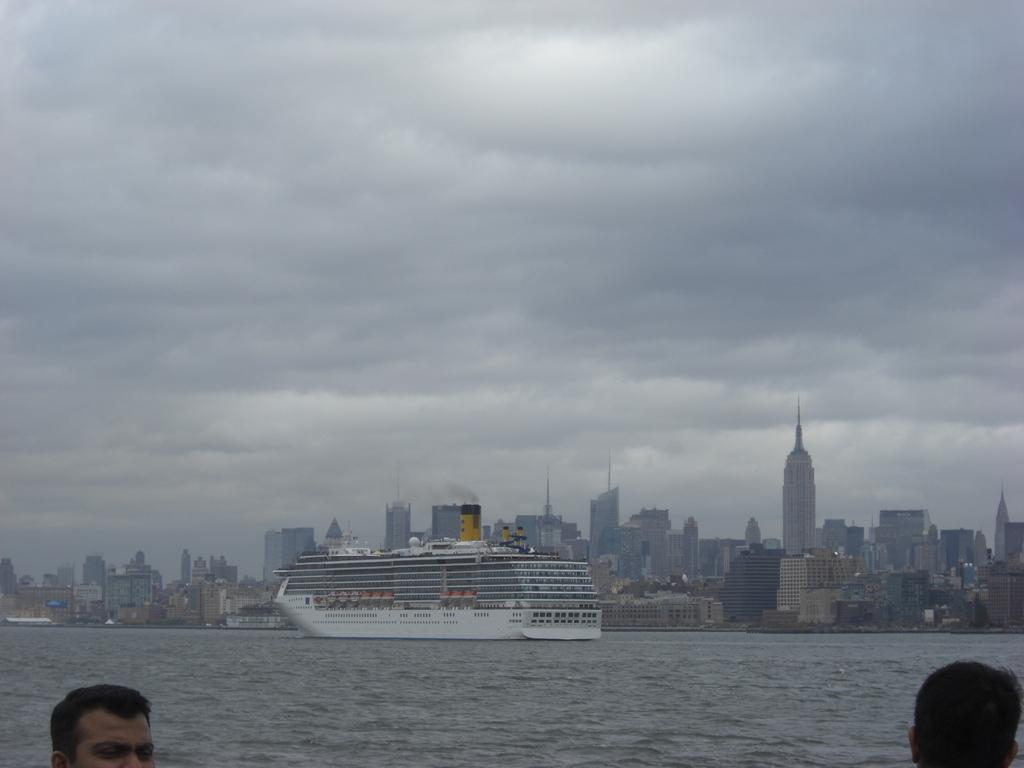What is the main subject in the center of the image? There is a ship in the center of the image. Where is the ship located? The ship is on the water. Can you describe the people at the bottom of the image? There are people at the bottom of the image, but their specific actions or activities are not mentioned in the facts. What can be seen in the background of the image? There are buildings and the sky visible in the background of the image. What type of pickle is being used as a navigational tool on the ship? There is no mention of a pickle in the image, and it is not a navigational tool. 